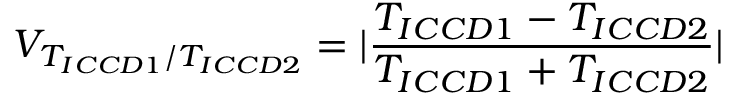<formula> <loc_0><loc_0><loc_500><loc_500>V _ { T _ { I C C D 1 } / T _ { I C C D 2 } } = | \frac { T _ { I C C D 1 } - T _ { I C C D 2 } } { T _ { I C C D 1 } + T _ { I C C D 2 } } |</formula> 